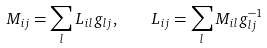Convert formula to latex. <formula><loc_0><loc_0><loc_500><loc_500>M _ { i j } = \sum _ { l } L _ { i l } g _ { l j } , \quad L _ { i j } = \sum _ { l } M _ { i l } g ^ { - 1 } _ { l j }</formula> 